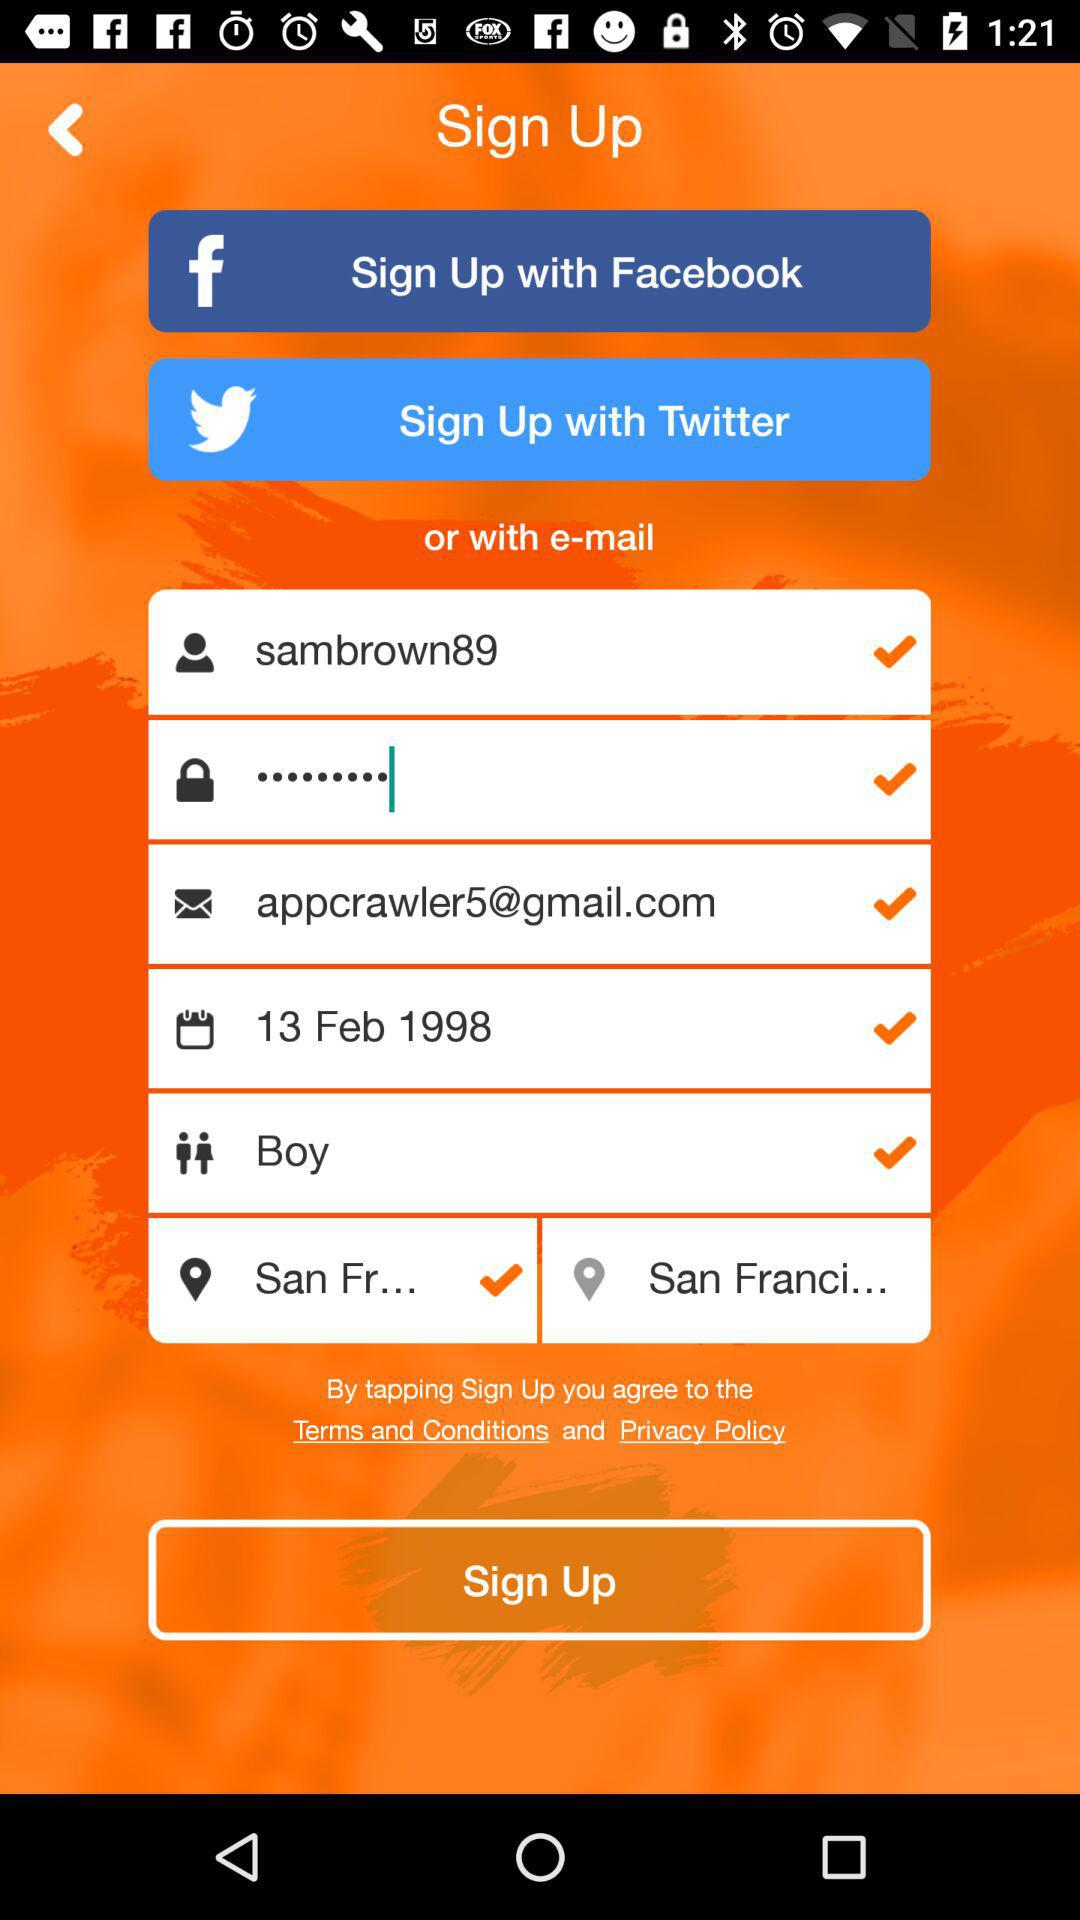What is the location? The location is "San Franci...". 